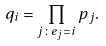<formula> <loc_0><loc_0><loc_500><loc_500>q _ { i } = \prod _ { j \colon e _ { j } = i } p _ { j } .</formula> 